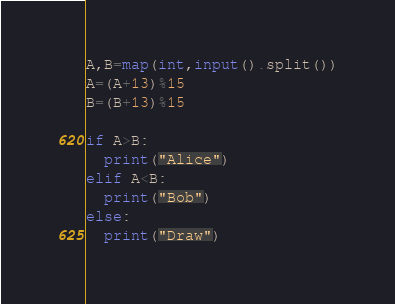<code> <loc_0><loc_0><loc_500><loc_500><_Python_>A,B=map(int,input().split())
A=(A+13)%15
B=(B+13)%15

if A>B:
  print("Alice")
elif A<B:
  print("Bob")
else:
  print("Draw")</code> 